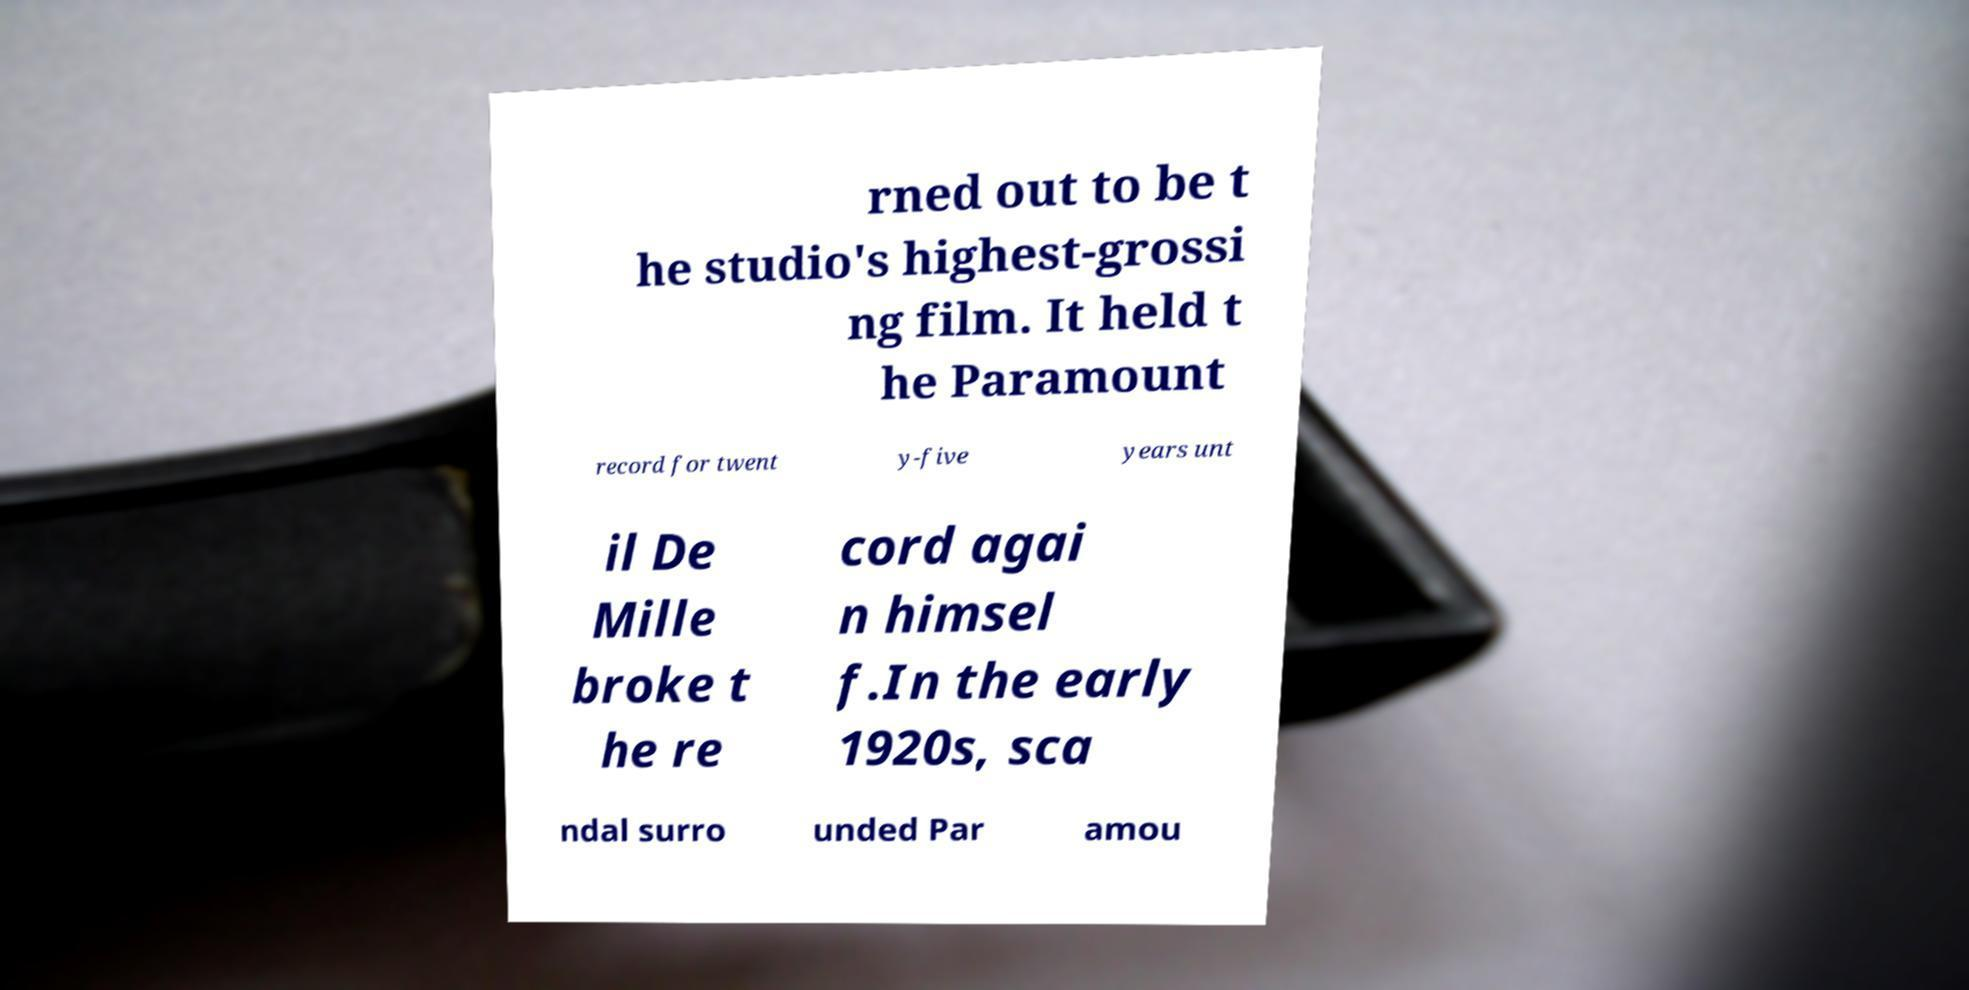Can you accurately transcribe the text from the provided image for me? rned out to be t he studio's highest-grossi ng film. It held t he Paramount record for twent y-five years unt il De Mille broke t he re cord agai n himsel f.In the early 1920s, sca ndal surro unded Par amou 